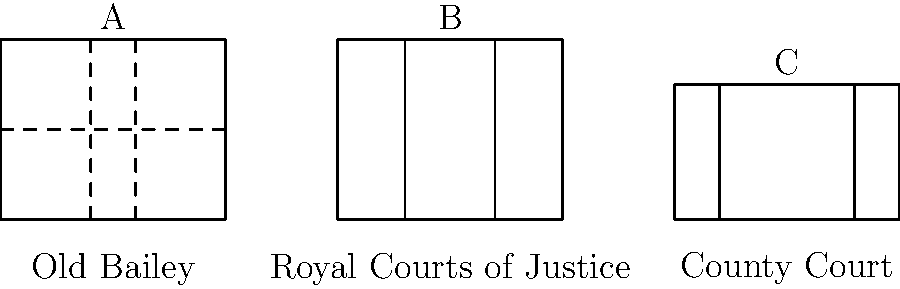Based on the architectural drawings provided, which of the 19th century UK court buildings is characterized by a symmetrical facade with two prominent wings and a central section? To answer this question, we need to analyze the architectural drawings of the three 19th century UK court buildings presented:

1. Building A (Old Bailey):
   - Rectangular shape
   - Three vertical sections indicated by dashed lines
   - One horizontal division

2. Building B (Royal Courts of Justice):
   - Rectangular shape
   - Three distinct vertical sections
   - No horizontal divisions
   - Symmetrical design with two prominent side sections and a central area

3. Building C (County Court):
   - Rectangular shape, shorter than the others
   - Three vertical sections
   - No horizontal divisions

The question asks for a building with a symmetrical facade, two prominent wings, and a central section. This description best matches Building B, the Royal Courts of Justice.

The Royal Courts of Justice, constructed in the late 19th century, is known for its Gothic revival style and symmetrical design. The drawing shows a clear division into three parts: two prominent side sections (wings) and a central area, which is characteristic of its actual architecture.

In contrast, the Old Bailey (Building A) has a more complex internal division, and the County Court (Building C) lacks the prominent wing structure described in the question.
Answer: Royal Courts of Justice 